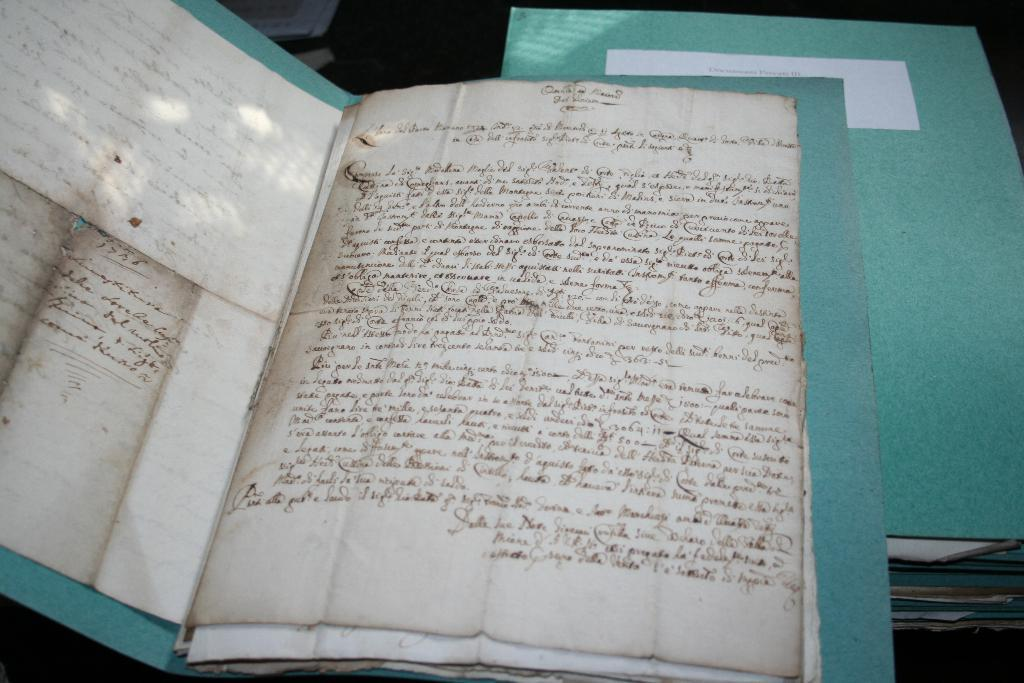What is located in the foreground of the image? There are papers in a file in the foreground of the image. What can be seen in the background of the image? There are many files on a black surface in the background of the image. What type of loaf is being used as a paperweight in the image? There is no loaf present in the image; it only features papers in a file and many files on a black surface. 